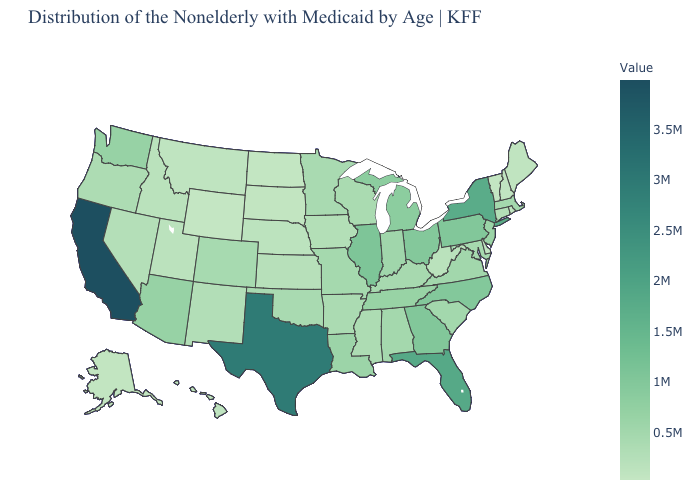Which states have the lowest value in the West?
Answer briefly. Wyoming. Does Washington have a lower value than Iowa?
Give a very brief answer. No. Which states have the highest value in the USA?
Quick response, please. California. Which states hav the highest value in the Northeast?
Keep it brief. New York. Which states have the highest value in the USA?
Concise answer only. California. Among the states that border Massachusetts , which have the highest value?
Concise answer only. New York. Among the states that border Illinois , does Indiana have the highest value?
Give a very brief answer. Yes. 